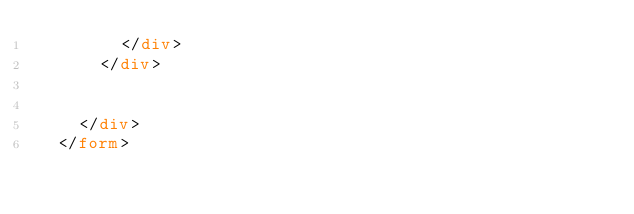<code> <loc_0><loc_0><loc_500><loc_500><_HTML_>        </div>
      </div>


    </div>
  </form>




</code> 